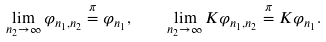Convert formula to latex. <formula><loc_0><loc_0><loc_500><loc_500>\lim _ { n _ { 2 } \to \infty } \varphi _ { n _ { 1 } , n _ { 2 } } \stackrel { \pi } { = } \varphi _ { n _ { 1 } } , \quad \lim _ { n _ { 2 } \to \infty } K \varphi _ { n _ { 1 } , n _ { 2 } } \stackrel { \pi } { = } K \varphi _ { n _ { 1 } } .</formula> 